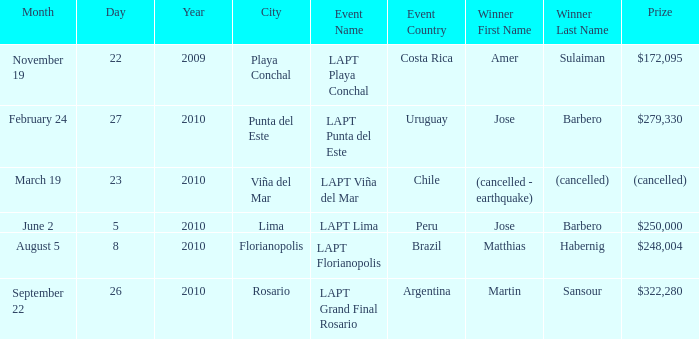What event is in florianopolis? LAPT Florianopolis - Brazil. 